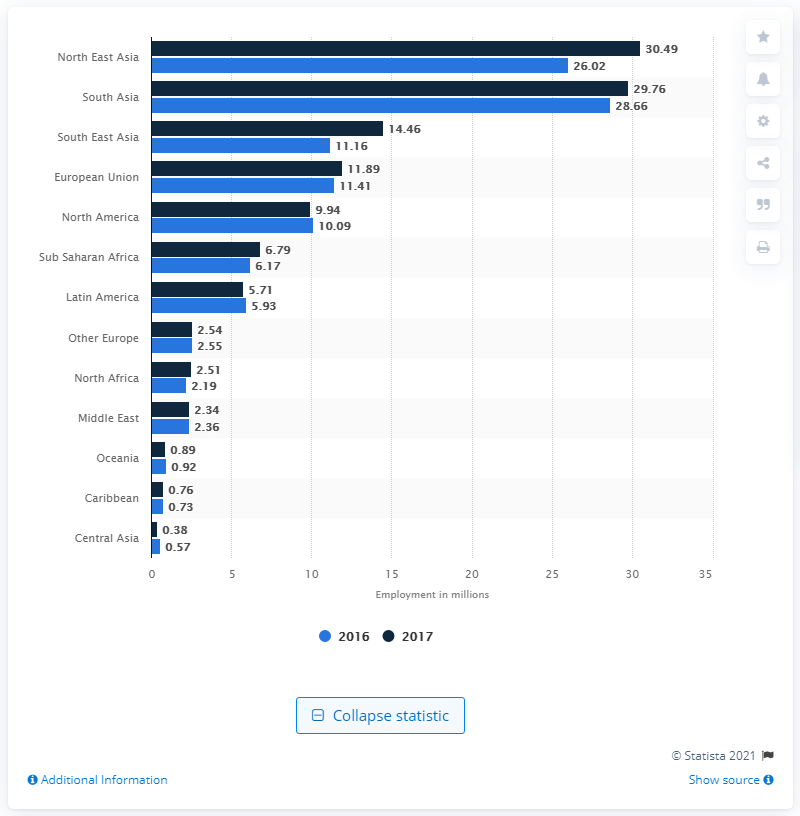Specify some key components in this picture. In 2017, the travel and tourism industry directly contributed 14.46 jobs to the South East Asian economy. 